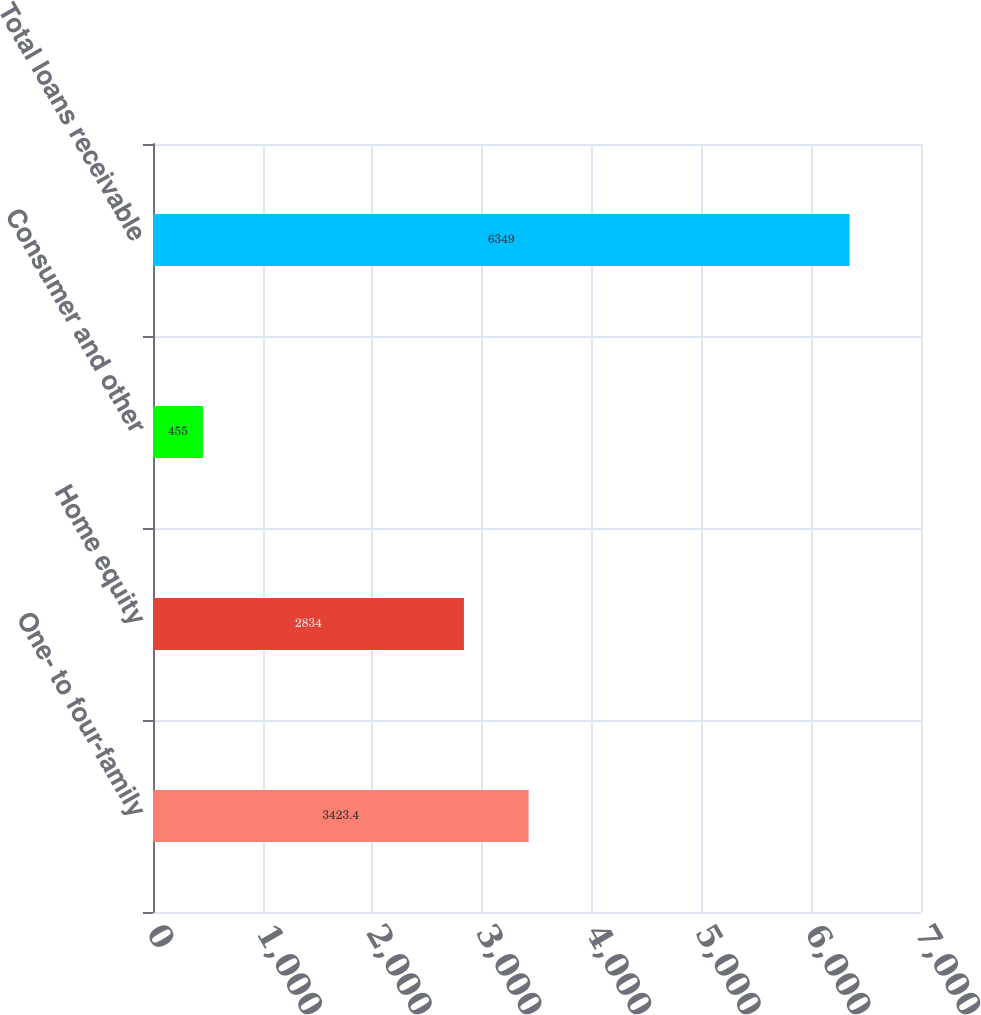Convert chart. <chart><loc_0><loc_0><loc_500><loc_500><bar_chart><fcel>One- to four-family<fcel>Home equity<fcel>Consumer and other<fcel>Total loans receivable<nl><fcel>3423.4<fcel>2834<fcel>455<fcel>6349<nl></chart> 